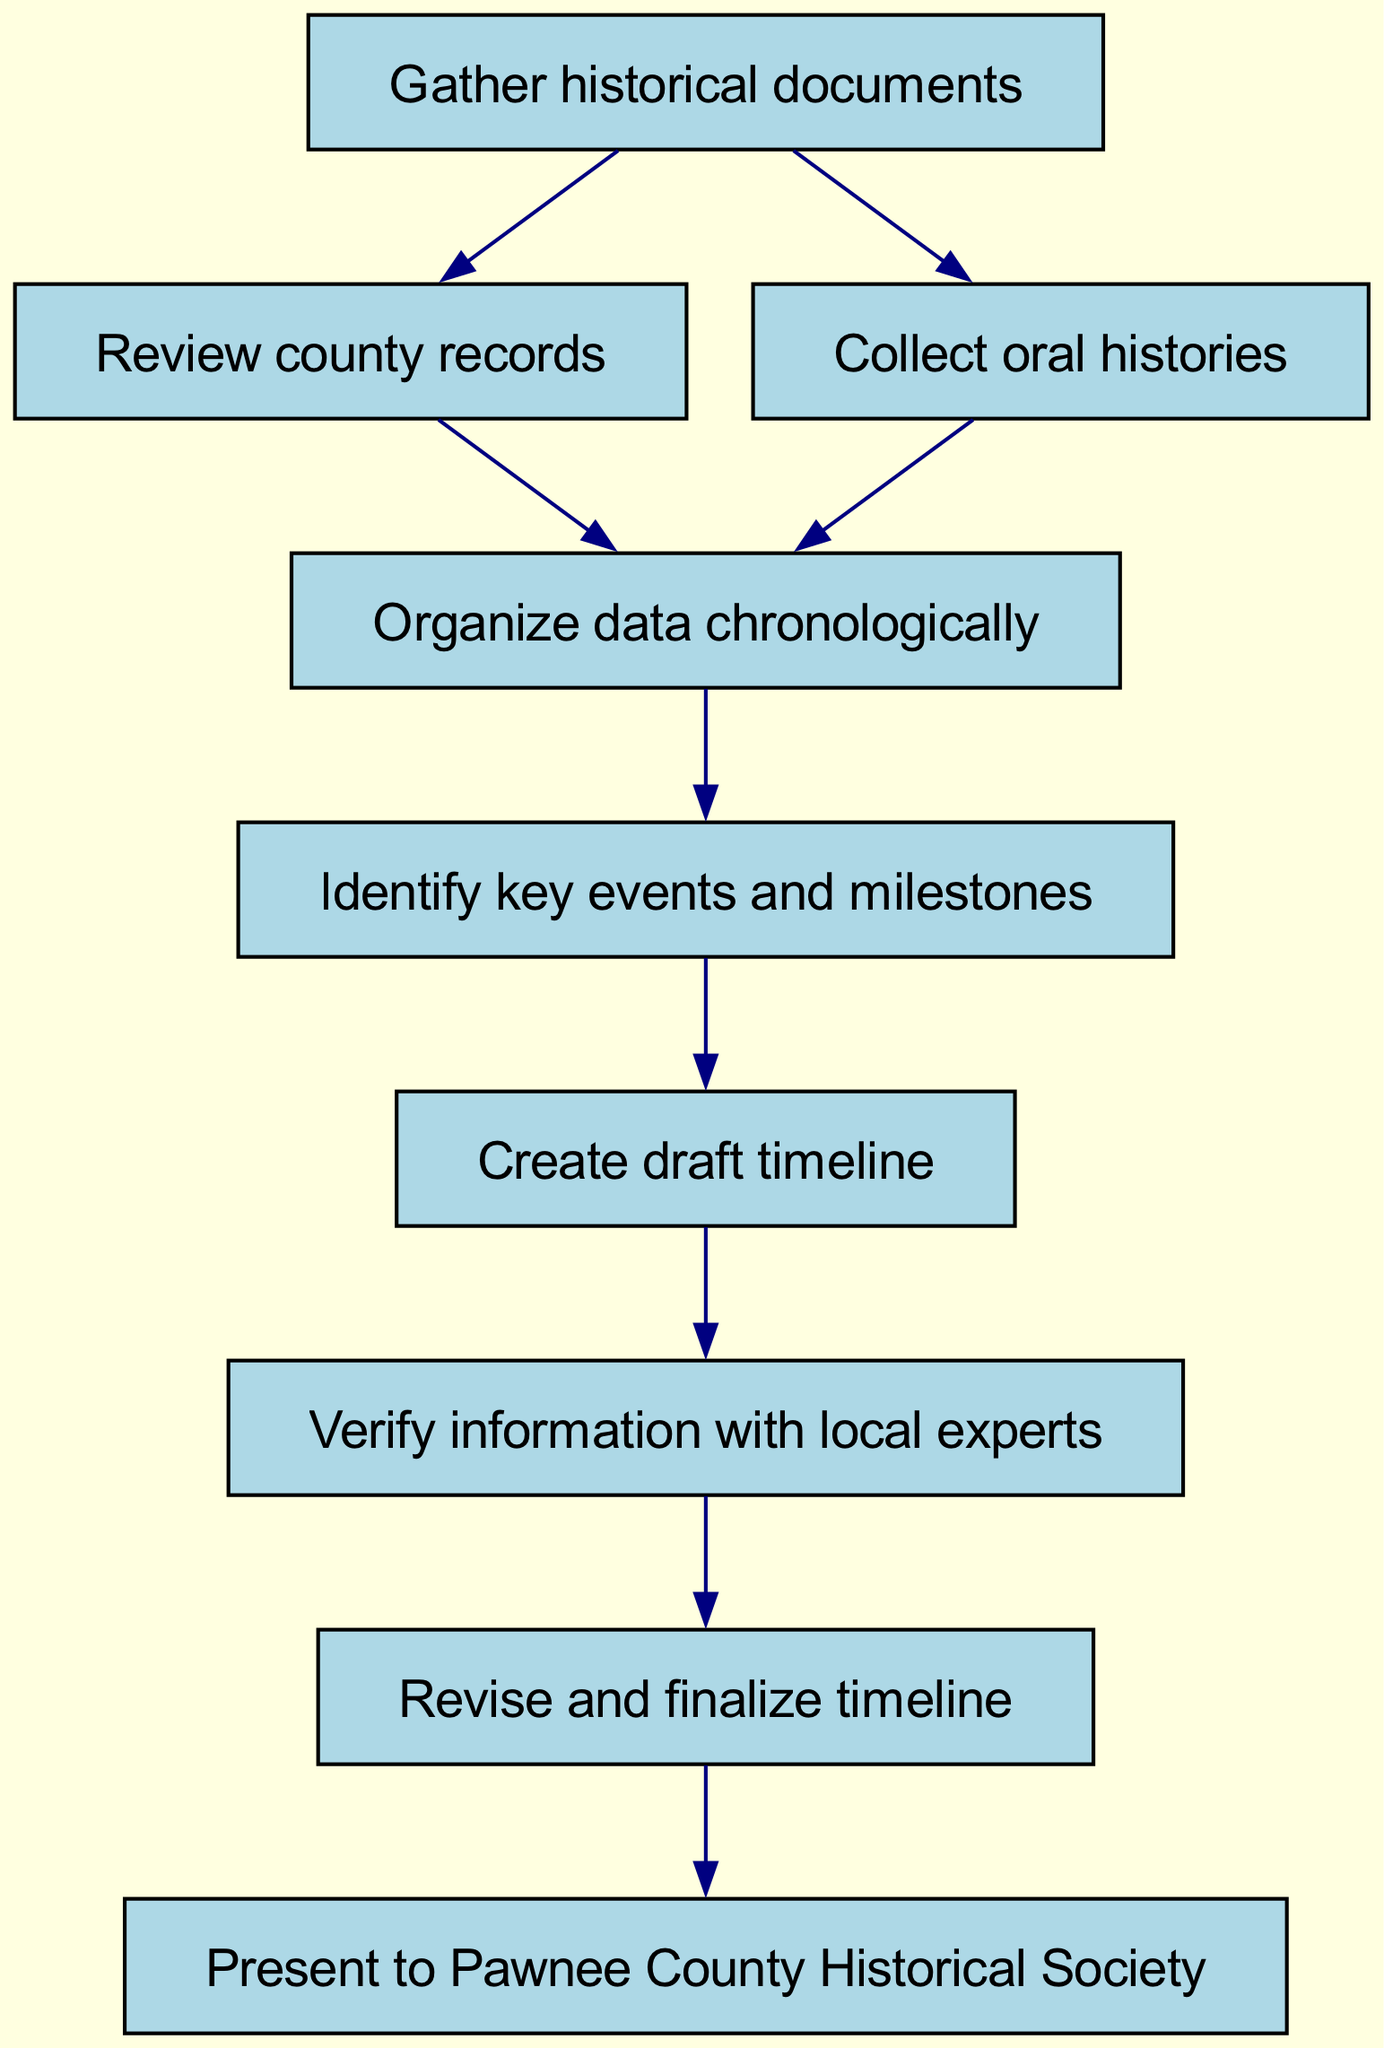What is the first step in the workflow? The diagram indicates that the workflow starts with "Gather historical documents," which is the first node in the flowchart.
Answer: Gather historical documents How many nodes are in the diagram? The diagram includes a total of 9 nodes, as each step of the workflow is represented by a distinct node from 1 to 9.
Answer: 9 What follows after "Collect oral histories"? The diagram shows that after "Collect oral histories," the next step is "Organize data chronologically," indicating a linear progression in the workflow.
Answer: Organize data chronologically Which steps are the last two in the sequence? The final two steps in the workflow are "Revise and finalize timeline" followed by "Present to Pawnee County Historical Society," indicating the completion and presentation phases of the workflow.
Answer: Revise and finalize timeline, Present to Pawnee County Historical Society What actions must be completed before creating a draft timeline? According to the diagram, both "Organize data chronologically" and "Identify key events and milestones" must be completed before progressing to "Create draft timeline." This requires completing two preceding steps.
Answer: Organize data chronologically, Identify key events and milestones 